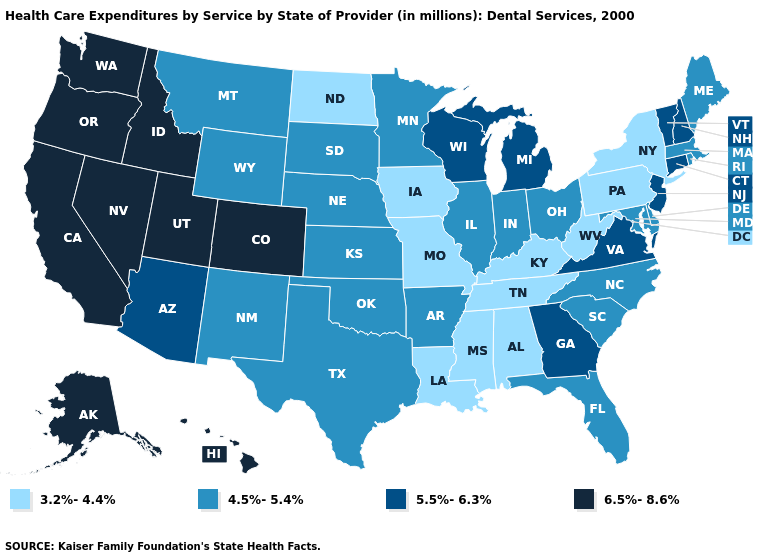What is the value of Hawaii?
Short answer required. 6.5%-8.6%. What is the value of Nebraska?
Keep it brief. 4.5%-5.4%. Which states have the lowest value in the South?
Write a very short answer. Alabama, Kentucky, Louisiana, Mississippi, Tennessee, West Virginia. Among the states that border Wyoming , does Nebraska have the lowest value?
Write a very short answer. Yes. How many symbols are there in the legend?
Quick response, please. 4. Which states have the highest value in the USA?
Give a very brief answer. Alaska, California, Colorado, Hawaii, Idaho, Nevada, Oregon, Utah, Washington. Does the first symbol in the legend represent the smallest category?
Concise answer only. Yes. Name the states that have a value in the range 5.5%-6.3%?
Short answer required. Arizona, Connecticut, Georgia, Michigan, New Hampshire, New Jersey, Vermont, Virginia, Wisconsin. Does Florida have the lowest value in the South?
Concise answer only. No. Does New Jersey have a lower value than Missouri?
Concise answer only. No. Among the states that border Virginia , which have the lowest value?
Quick response, please. Kentucky, Tennessee, West Virginia. What is the lowest value in states that border North Carolina?
Keep it brief. 3.2%-4.4%. Name the states that have a value in the range 6.5%-8.6%?
Quick response, please. Alaska, California, Colorado, Hawaii, Idaho, Nevada, Oregon, Utah, Washington. What is the value of Vermont?
Quick response, please. 5.5%-6.3%. What is the value of Oregon?
Quick response, please. 6.5%-8.6%. 